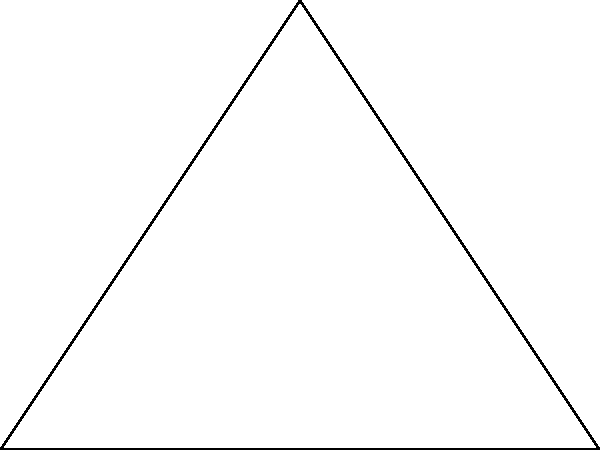A new suburban development in the outskirts of Chicago is planning to create a triangular park. The surveyor has measured two sides of the triangular plot: the base is 8 yards, and one of the other sides is 6 yards. If these two sides form a right angle, what is the area of the triangular park in square yards? To solve this problem, we'll use the formula for the area of a right triangle:

$$\text{Area} = \frac{1}{2} \times \text{base} \times \text{height}$$

Given:
- The base of the triangle is 8 yards
- One side (which forms the height in this case) is 6 yards
- The angle between these sides is a right angle (90°)

Step 1: Plug the values into the formula
$$\text{Area} = \frac{1}{2} \times 8 \text{ yards} \times 6 \text{ yards}$$

Step 2: Multiply
$$\text{Area} = \frac{1}{2} \times 48 \text{ square yards}$$

Step 3: Simplify
$$\text{Area} = 24 \text{ square yards}$$

Therefore, the area of the triangular park is 24 square yards.
Answer: 24 square yards 